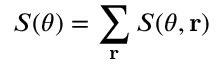<formula> <loc_0><loc_0><loc_500><loc_500>S ( \theta ) = \sum _ { r } S ( \theta , { r } )</formula> 